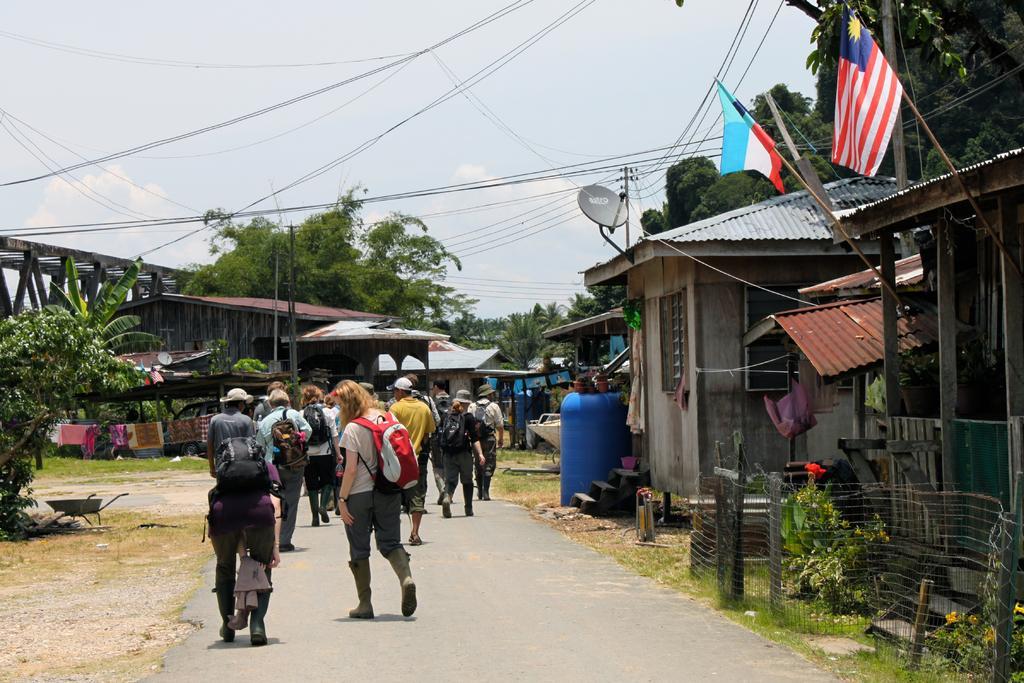Can you describe this image briefly? In this image there are some persons standing on the road in the bottom of this image. there are some houses on the right side of this image and left side of this image as well. There are some trees in the background. There is a sky on the top of this image. 